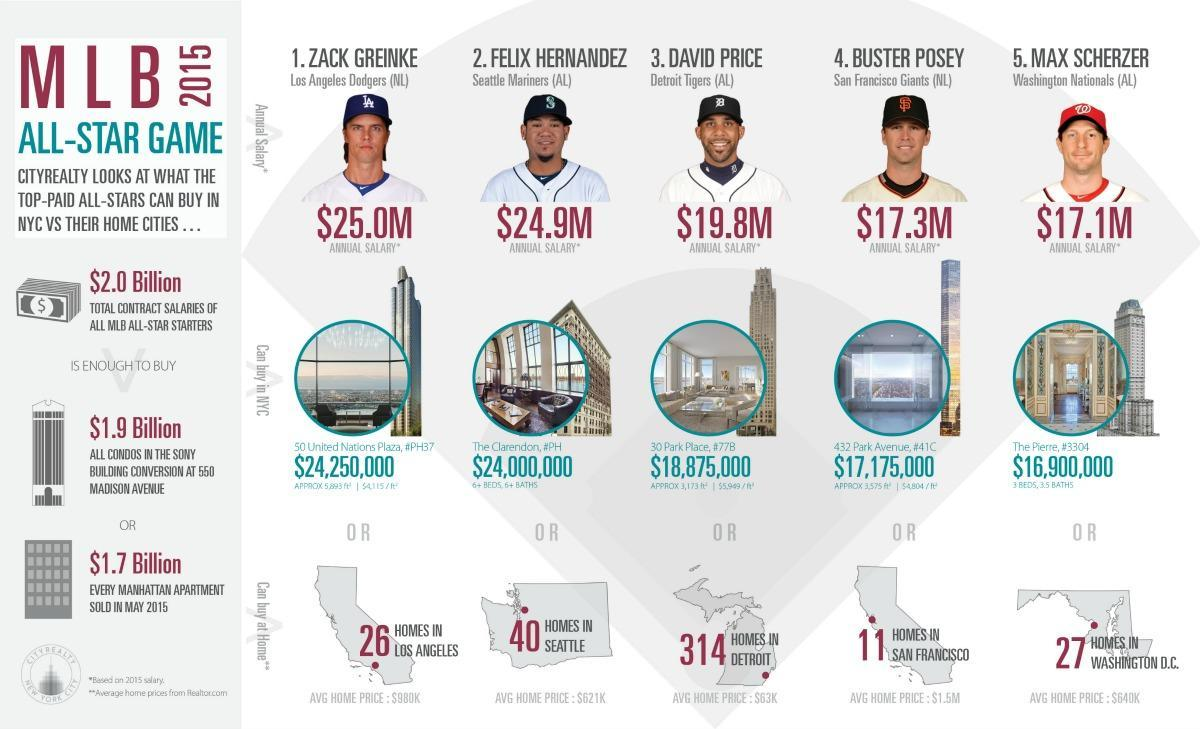To which Team David Price belongs?
Answer the question with a short phrase. Detroit Tigers What is the annual salary of Buster Posey? $17.3M What is the annual salary of David Price? $ 19.8M To which Team Max Scherzer belongs? Washington Nationals (AL) How much is the area of 432 Park Avenue in square feet? 3,575 How many homes could be bought by David Price in his own country? 314 homes What is the average price of a home in Seattle? $621K Who has the second-highest salary among the players? Felix Hernandez How much is the salary amount (million dollars) if David Price and Buster Posey taken together? 37.1 Which player could buy 40 Homes in Seattle? Felix Hernandez 